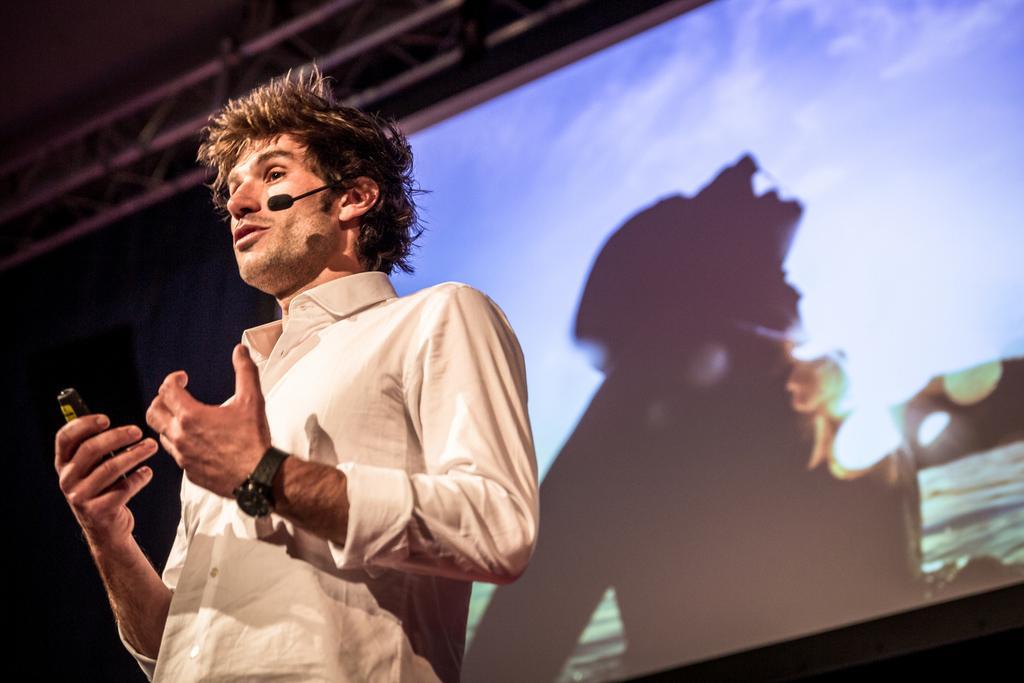How would you summarize this image in a sentence or two? This picture is clicked inside. On the left there is a person wearing shirt, holding an object, standing and seems to be talking. In the background we can see the projector screen and the metal rods and on the projector screen we can see the pictures of some objects. 